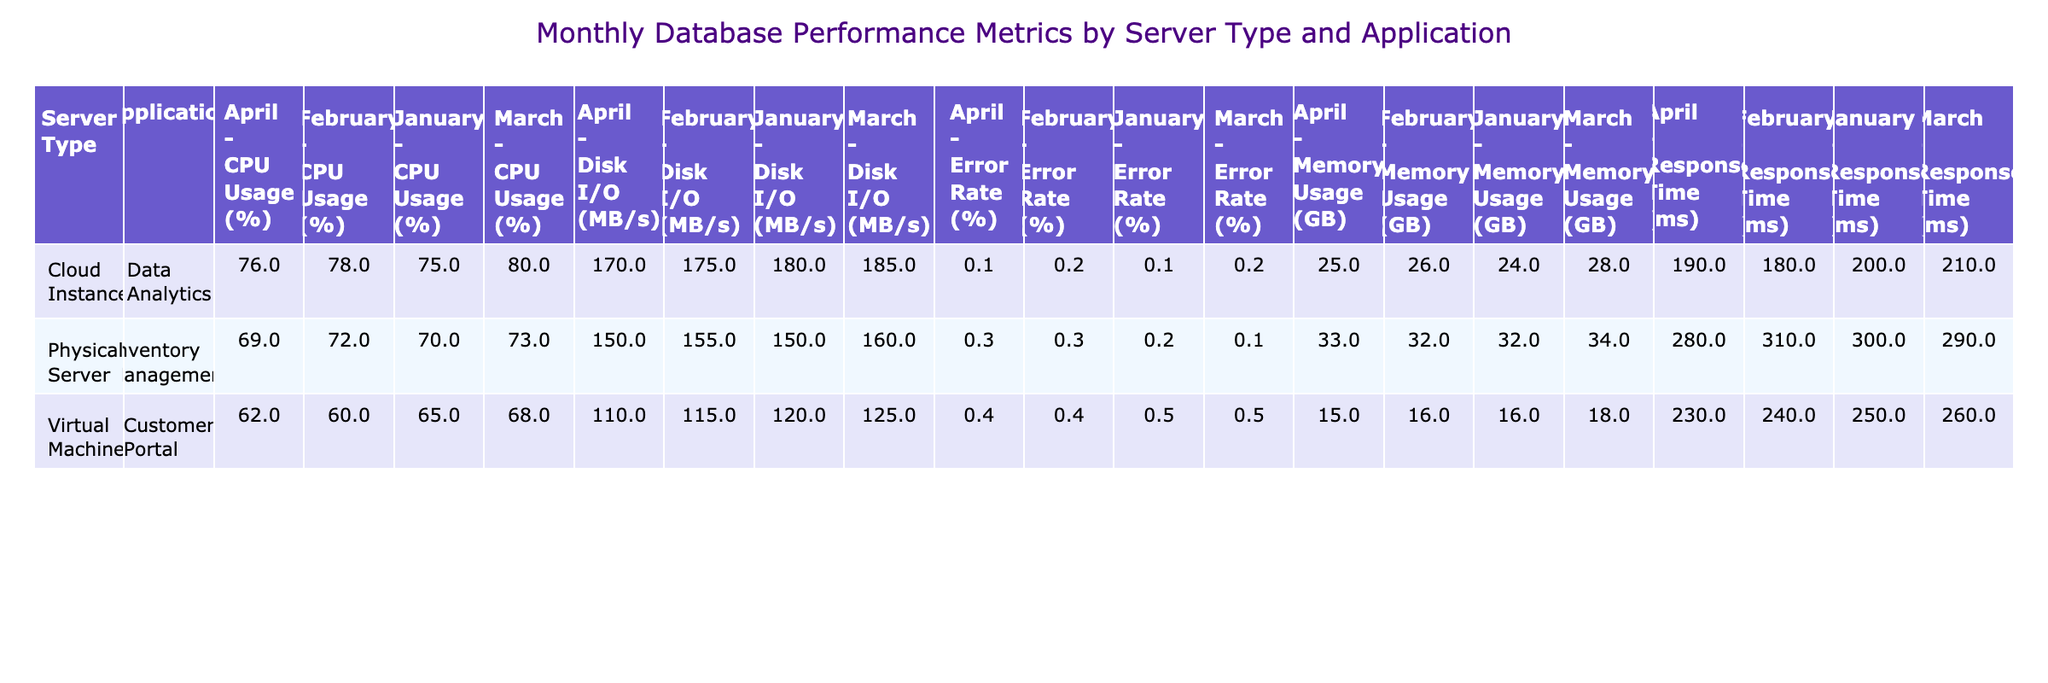What was the CPU Usage for the Cloud Instance running Data Analytics in March? The table shows that the CPU Usage for the Cloud Instance running Data Analytics in March is 80%.
Answer: 80% What is the average Memory Usage for the Virtual Machine running Customer Portal across all months? To find the average Memory Usage for the Virtual Machine running Customer Portal, we consider the values for January (16 GB), February (16 GB), March (18 GB), and April (15 GB). The sum is (16 + 16 + 18 + 15) = 65 GB. There are 4 months, so the average is 65/4 = 16.25 GB.
Answer: 16.25 GB Did the Error Rate for Physical Server running Inventory Management decrease from January to April? In January, the Error Rate was 0.2% and in April it was 0.3%. Since 0.3% is greater than 0.2%, the Error Rate actually increased.
Answer: No Which server type had the highest Disk I/O in February? Evaluating the Disk I/O values for February: Virtual Machine (115 MB/s), Physical Server (155 MB/s), and Cloud Instance (175 MB/s). The highest value is from the Cloud Instance at 175 MB/s.
Answer: Cloud Instance What is the total Response Time for the Cloud Instance running Data Analytics across all months? The Response Times for the Cloud Instance running Data Analytics are: January (200 ms), February (180 ms), March (210 ms), and April (190 ms). The total is (200 + 180 + 210 + 190) = 780 ms.
Answer: 780 ms What was the highest CPU Usage recorded for any server type across all months? We need to check all CPU Usage values: 65%, 70%, 75%, 60%, 72%, 78%, 68%, 69%, 80%. The highest value is 80% recorded by the Cloud Instance in March.
Answer: 80% Was the Memory Usage for the Physical Server running Inventory Management consistently higher than the Virtual Machine running Customer Portal in all months? We compare the Memory Usage: January (32 GB vs 16 GB, yes), February (32 GB vs 16 GB, yes), March (34 GB vs 18 GB, yes), April (33 GB vs 15 GB, yes). The Physical Server's Memory Usage was higher in all months.
Answer: Yes How much more Disk I/O did the Physical Server running Inventory Management have compared to the Virtual Machine running Customer Portal in January? The Disk I/O for Physical Server in January is 150 MB/s and for Virtual Machine it is 120 MB/s. The difference is 150 - 120 = 30 MB/s.
Answer: 30 MB/s Which application showed the least amount of CPU Usage in April? In April, the CPU Usage values are: Customer Portal (62%), Inventory Management (69%), and Data Analytics (76%). The least amount of CPU Usage was recorded by the Customer Portal at 62%.
Answer: Customer Portal 